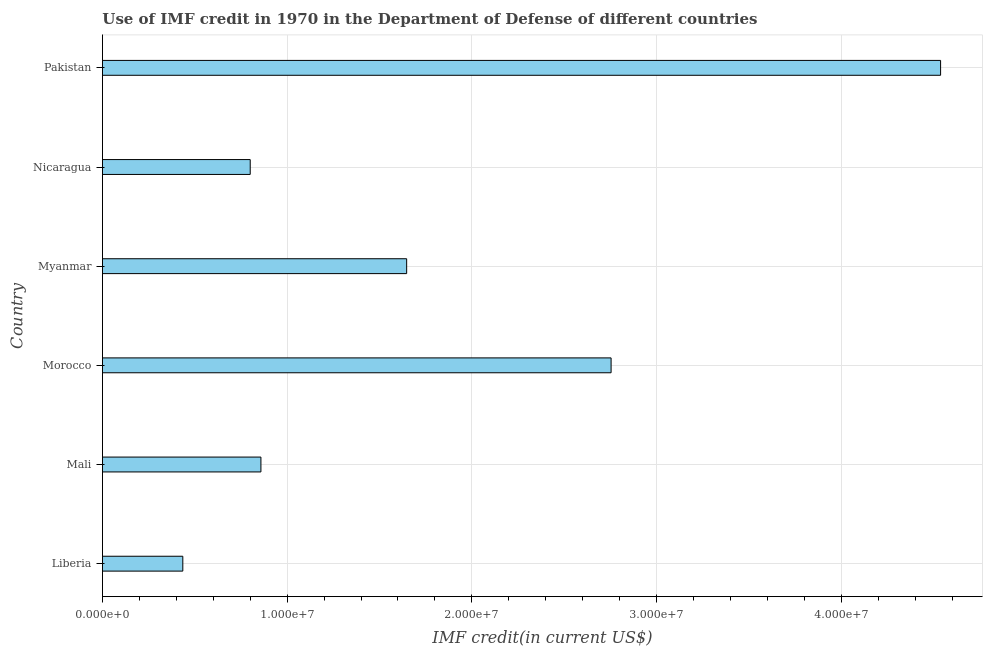Does the graph contain grids?
Provide a short and direct response. Yes. What is the title of the graph?
Your answer should be very brief. Use of IMF credit in 1970 in the Department of Defense of different countries. What is the label or title of the X-axis?
Ensure brevity in your answer.  IMF credit(in current US$). What is the label or title of the Y-axis?
Offer a terse response. Country. What is the use of imf credit in dod in Myanmar?
Offer a terse response. 1.65e+07. Across all countries, what is the maximum use of imf credit in dod?
Ensure brevity in your answer.  4.54e+07. Across all countries, what is the minimum use of imf credit in dod?
Offer a terse response. 4.35e+06. In which country was the use of imf credit in dod maximum?
Your answer should be compact. Pakistan. In which country was the use of imf credit in dod minimum?
Provide a short and direct response. Liberia. What is the sum of the use of imf credit in dod?
Your answer should be very brief. 1.10e+08. What is the difference between the use of imf credit in dod in Mali and Pakistan?
Keep it short and to the point. -3.68e+07. What is the average use of imf credit in dod per country?
Your response must be concise. 1.84e+07. What is the median use of imf credit in dod?
Provide a succinct answer. 1.25e+07. In how many countries, is the use of imf credit in dod greater than 34000000 US$?
Provide a succinct answer. 1. What is the ratio of the use of imf credit in dod in Myanmar to that in Nicaragua?
Your answer should be very brief. 2.06. Is the use of imf credit in dod in Mali less than that in Nicaragua?
Keep it short and to the point. No. What is the difference between the highest and the second highest use of imf credit in dod?
Keep it short and to the point. 1.78e+07. Is the sum of the use of imf credit in dod in Liberia and Mali greater than the maximum use of imf credit in dod across all countries?
Provide a succinct answer. No. What is the difference between the highest and the lowest use of imf credit in dod?
Give a very brief answer. 4.10e+07. In how many countries, is the use of imf credit in dod greater than the average use of imf credit in dod taken over all countries?
Your answer should be compact. 2. How many bars are there?
Make the answer very short. 6. Are all the bars in the graph horizontal?
Keep it short and to the point. Yes. How many countries are there in the graph?
Offer a very short reply. 6. What is the IMF credit(in current US$) of Liberia?
Your answer should be very brief. 4.35e+06. What is the IMF credit(in current US$) in Mali?
Offer a terse response. 8.58e+06. What is the IMF credit(in current US$) in Morocco?
Keep it short and to the point. 2.75e+07. What is the IMF credit(in current US$) in Myanmar?
Ensure brevity in your answer.  1.65e+07. What is the IMF credit(in current US$) in Nicaragua?
Your answer should be compact. 8.00e+06. What is the IMF credit(in current US$) in Pakistan?
Your response must be concise. 4.54e+07. What is the difference between the IMF credit(in current US$) in Liberia and Mali?
Provide a succinct answer. -4.23e+06. What is the difference between the IMF credit(in current US$) in Liberia and Morocco?
Provide a succinct answer. -2.32e+07. What is the difference between the IMF credit(in current US$) in Liberia and Myanmar?
Keep it short and to the point. -1.21e+07. What is the difference between the IMF credit(in current US$) in Liberia and Nicaragua?
Keep it short and to the point. -3.65e+06. What is the difference between the IMF credit(in current US$) in Liberia and Pakistan?
Make the answer very short. -4.10e+07. What is the difference between the IMF credit(in current US$) in Mali and Morocco?
Keep it short and to the point. -1.90e+07. What is the difference between the IMF credit(in current US$) in Mali and Myanmar?
Provide a short and direct response. -7.89e+06. What is the difference between the IMF credit(in current US$) in Mali and Nicaragua?
Make the answer very short. 5.80e+05. What is the difference between the IMF credit(in current US$) in Mali and Pakistan?
Give a very brief answer. -3.68e+07. What is the difference between the IMF credit(in current US$) in Morocco and Myanmar?
Provide a succinct answer. 1.11e+07. What is the difference between the IMF credit(in current US$) in Morocco and Nicaragua?
Offer a terse response. 1.95e+07. What is the difference between the IMF credit(in current US$) in Morocco and Pakistan?
Provide a succinct answer. -1.78e+07. What is the difference between the IMF credit(in current US$) in Myanmar and Nicaragua?
Ensure brevity in your answer.  8.47e+06. What is the difference between the IMF credit(in current US$) in Myanmar and Pakistan?
Your answer should be compact. -2.89e+07. What is the difference between the IMF credit(in current US$) in Nicaragua and Pakistan?
Offer a terse response. -3.74e+07. What is the ratio of the IMF credit(in current US$) in Liberia to that in Mali?
Offer a terse response. 0.51. What is the ratio of the IMF credit(in current US$) in Liberia to that in Morocco?
Provide a short and direct response. 0.16. What is the ratio of the IMF credit(in current US$) in Liberia to that in Myanmar?
Your answer should be very brief. 0.26. What is the ratio of the IMF credit(in current US$) in Liberia to that in Nicaragua?
Give a very brief answer. 0.54. What is the ratio of the IMF credit(in current US$) in Liberia to that in Pakistan?
Keep it short and to the point. 0.1. What is the ratio of the IMF credit(in current US$) in Mali to that in Morocco?
Give a very brief answer. 0.31. What is the ratio of the IMF credit(in current US$) in Mali to that in Myanmar?
Provide a succinct answer. 0.52. What is the ratio of the IMF credit(in current US$) in Mali to that in Nicaragua?
Offer a terse response. 1.07. What is the ratio of the IMF credit(in current US$) in Mali to that in Pakistan?
Provide a short and direct response. 0.19. What is the ratio of the IMF credit(in current US$) in Morocco to that in Myanmar?
Your answer should be very brief. 1.67. What is the ratio of the IMF credit(in current US$) in Morocco to that in Nicaragua?
Ensure brevity in your answer.  3.44. What is the ratio of the IMF credit(in current US$) in Morocco to that in Pakistan?
Provide a succinct answer. 0.61. What is the ratio of the IMF credit(in current US$) in Myanmar to that in Nicaragua?
Provide a short and direct response. 2.06. What is the ratio of the IMF credit(in current US$) in Myanmar to that in Pakistan?
Make the answer very short. 0.36. What is the ratio of the IMF credit(in current US$) in Nicaragua to that in Pakistan?
Provide a succinct answer. 0.18. 